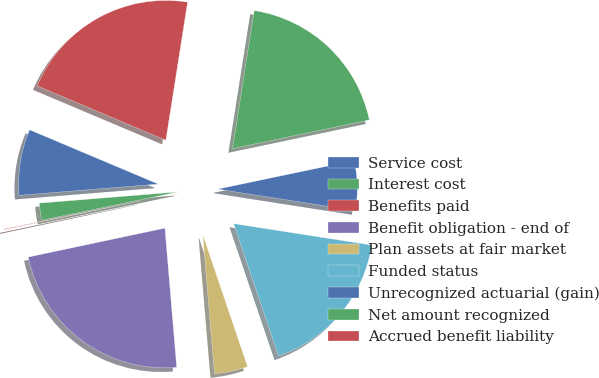<chart> <loc_0><loc_0><loc_500><loc_500><pie_chart><fcel>Service cost<fcel>Interest cost<fcel>Benefits paid<fcel>Benefit obligation - end of<fcel>Plan assets at fair market<fcel>Funded status<fcel>Unrecognized actuarial (gain)<fcel>Net amount recognized<fcel>Accrued benefit liability<nl><fcel>7.64%<fcel>1.97%<fcel>0.07%<fcel>23.02%<fcel>3.86%<fcel>17.34%<fcel>5.75%<fcel>19.23%<fcel>21.13%<nl></chart> 